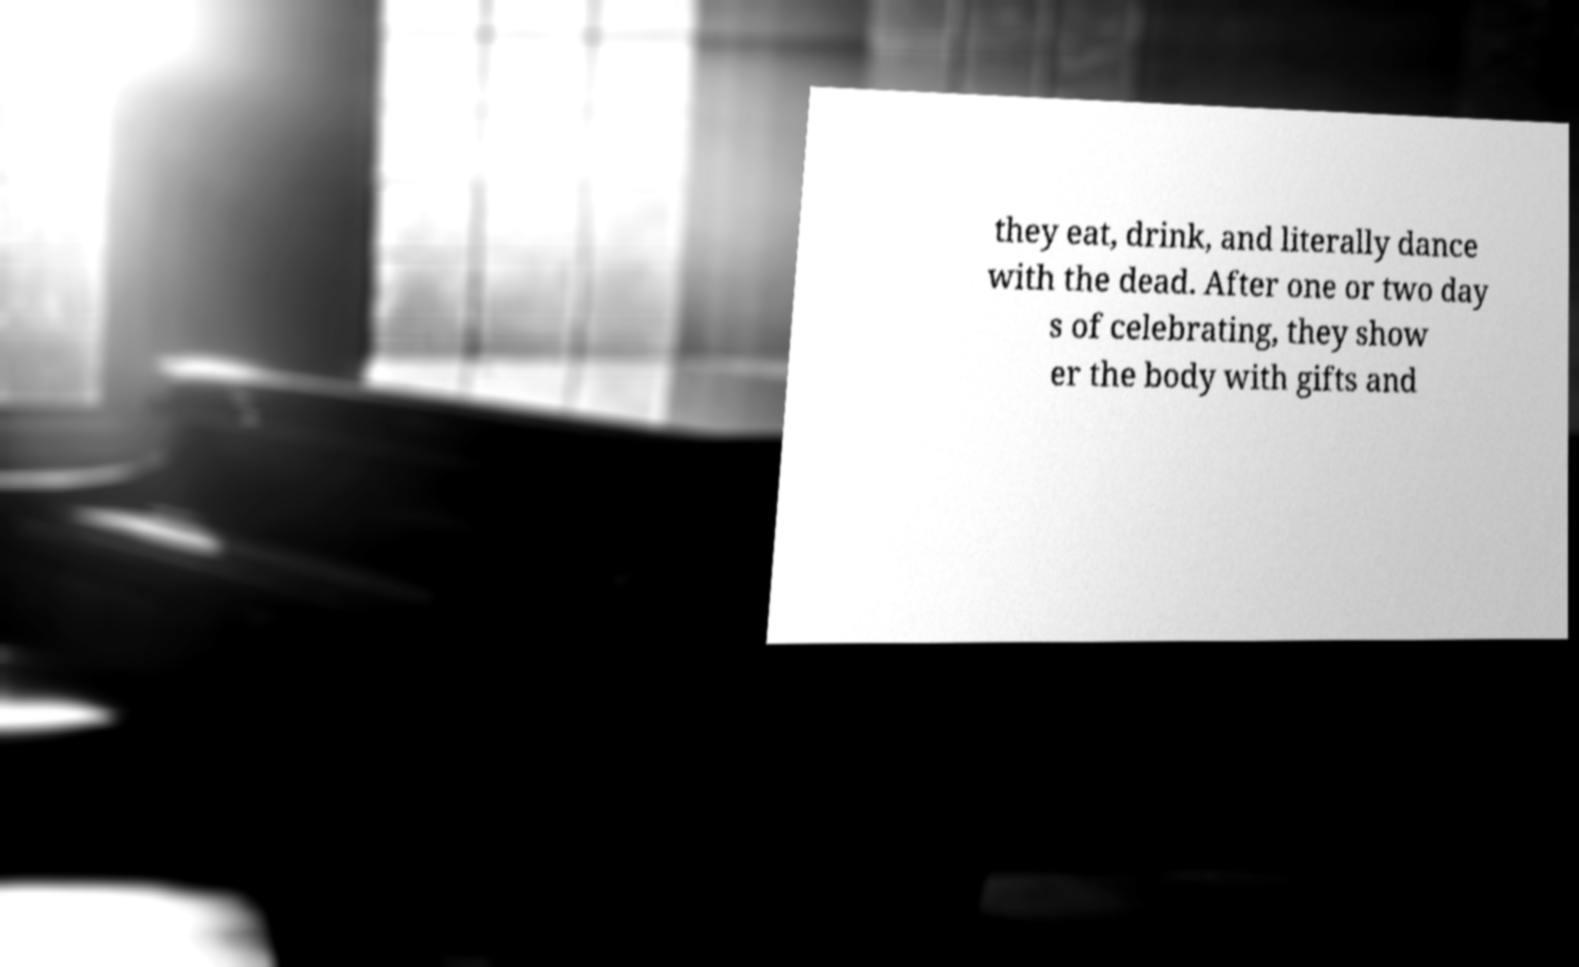What messages or text are displayed in this image? I need them in a readable, typed format. they eat, drink, and literally dance with the dead. After one or two day s of celebrating, they show er the body with gifts and 